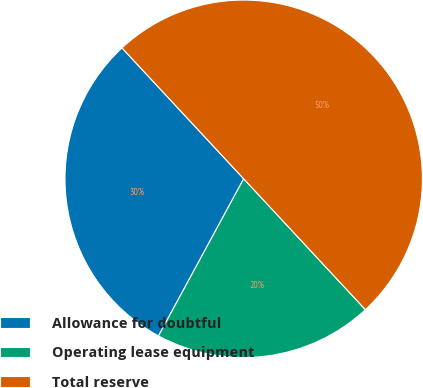<chart> <loc_0><loc_0><loc_500><loc_500><pie_chart><fcel>Allowance for doubtful<fcel>Operating lease equipment<fcel>Total reserve<nl><fcel>30.17%<fcel>19.83%<fcel>50.0%<nl></chart> 